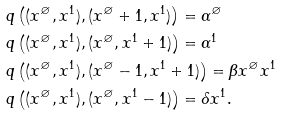<formula> <loc_0><loc_0><loc_500><loc_500>& q \left ( ( x ^ { \varnothing } , x ^ { 1 } ) , ( x ^ { \varnothing } + 1 , x ^ { 1 } ) \right ) = \alpha ^ { \varnothing } \\ & q \left ( ( x ^ { \varnothing } , x ^ { 1 } ) , ( x ^ { \varnothing } , x ^ { 1 } + 1 ) \right ) = \alpha ^ { 1 } \\ & q \left ( ( x ^ { \varnothing } , x ^ { 1 } ) , ( x ^ { \varnothing } - 1 , x ^ { 1 } + 1 ) \right ) = \beta x ^ { \varnothing } x ^ { 1 } \\ & q \left ( ( x ^ { \varnothing } , x ^ { 1 } ) , ( x ^ { \varnothing } , x ^ { 1 } - 1 ) \right ) = \delta x ^ { 1 } .</formula> 